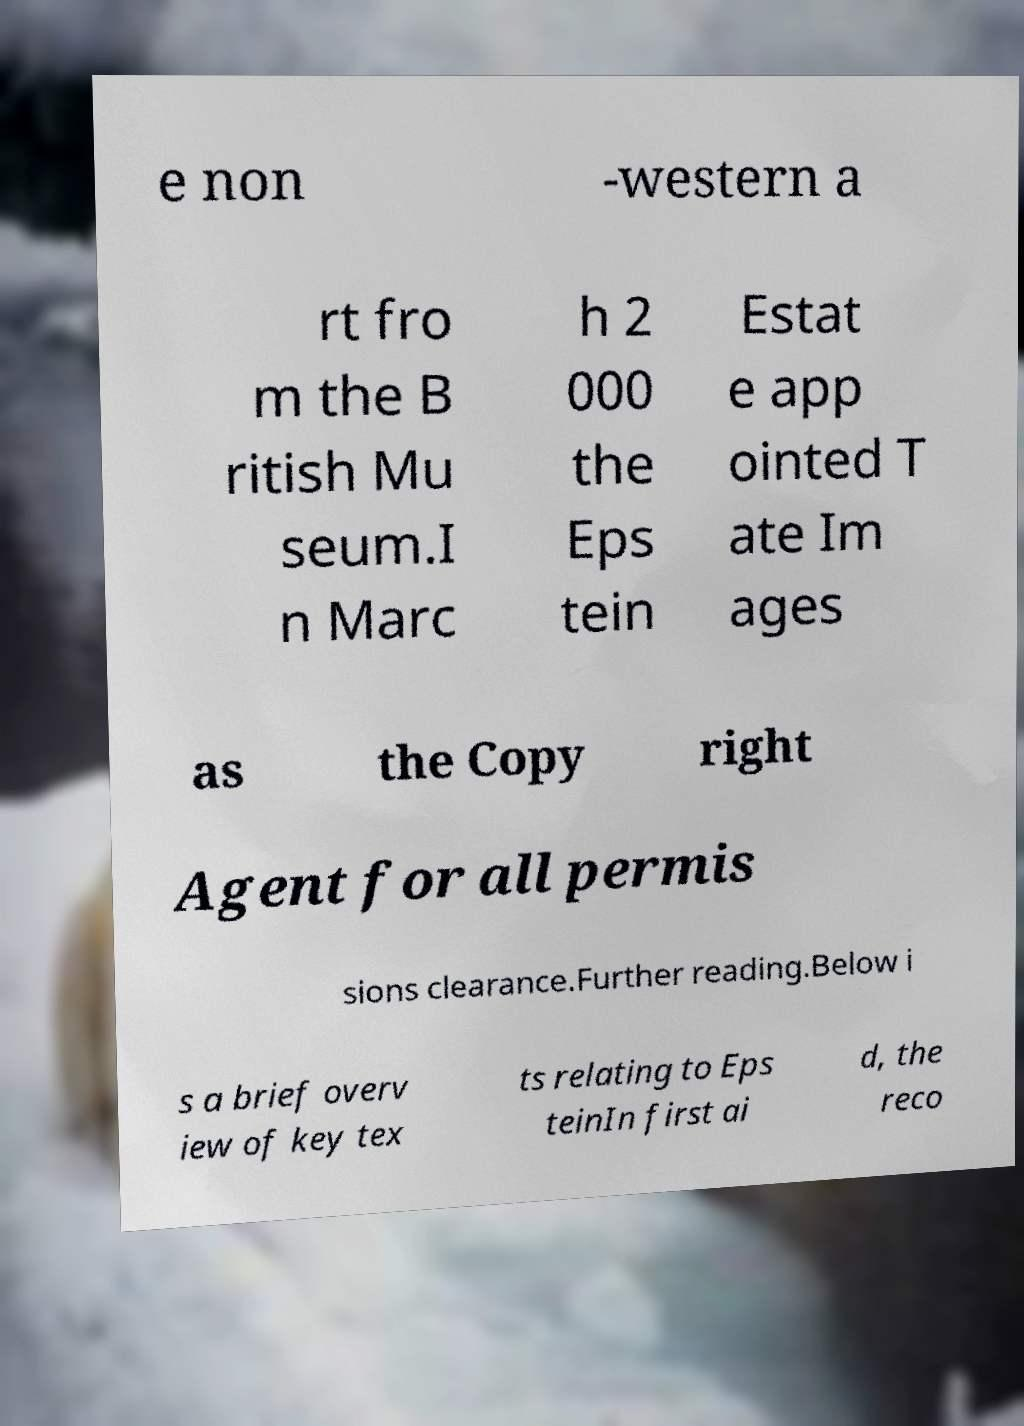Please read and relay the text visible in this image. What does it say? e non -western a rt fro m the B ritish Mu seum.I n Marc h 2 000 the Eps tein Estat e app ointed T ate Im ages as the Copy right Agent for all permis sions clearance.Further reading.Below i s a brief overv iew of key tex ts relating to Eps teinIn first ai d, the reco 